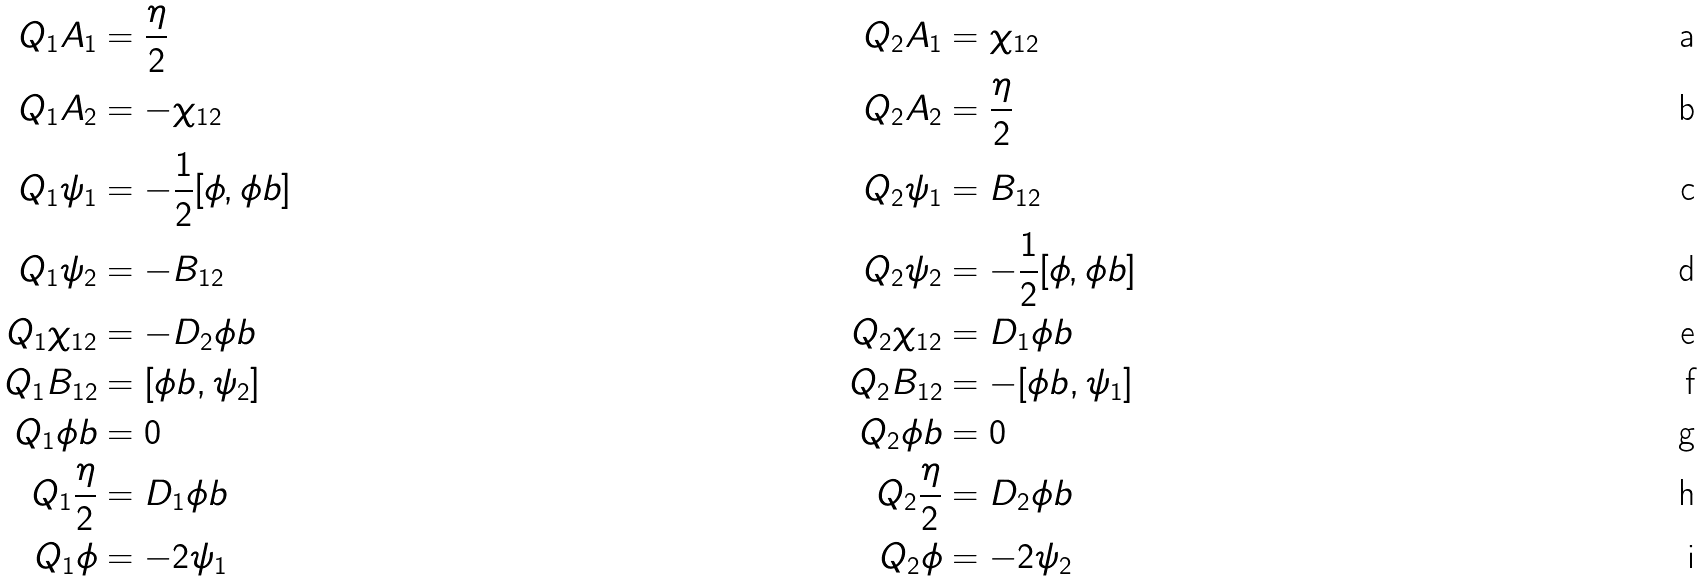Convert formula to latex. <formula><loc_0><loc_0><loc_500><loc_500>Q _ { 1 } A _ { 1 } & = \frac { \eta } { 2 } & Q _ { 2 } A _ { 1 } & = \chi _ { 1 2 } \\ Q _ { 1 } A _ { 2 } & = - \chi _ { 1 2 } & Q _ { 2 } A _ { 2 } & = \frac { \eta } { 2 } \\ Q _ { 1 } \psi _ { 1 } & = - \frac { 1 } { 2 } [ \phi , \phi b ] & Q _ { 2 } \psi _ { 1 } & = B _ { 1 2 } \\ Q _ { 1 } \psi _ { 2 } & = - B _ { 1 2 } & Q _ { 2 } \psi _ { 2 } & = - \frac { 1 } { 2 } [ \phi , \phi b ] \\ Q _ { 1 } \chi _ { 1 2 } & = - D _ { 2 } \phi b & Q _ { 2 } \chi _ { 1 2 } & = D _ { 1 } \phi b \\ Q _ { 1 } B _ { 1 2 } & = [ \phi b , \psi _ { 2 } ] & Q _ { 2 } B _ { 1 2 } & = - [ \phi b , \psi _ { 1 } ] \\ Q _ { 1 } \phi b & = 0 & Q _ { 2 } \phi b & = 0 \\ Q _ { 1 } \frac { \eta } { 2 } & = D _ { 1 } \phi b & Q _ { 2 } \frac { \eta } { 2 } & = D _ { 2 } \phi b \\ Q _ { 1 } \phi & = - 2 \psi _ { 1 } & Q _ { 2 } \phi & = - 2 \psi _ { 2 }</formula> 